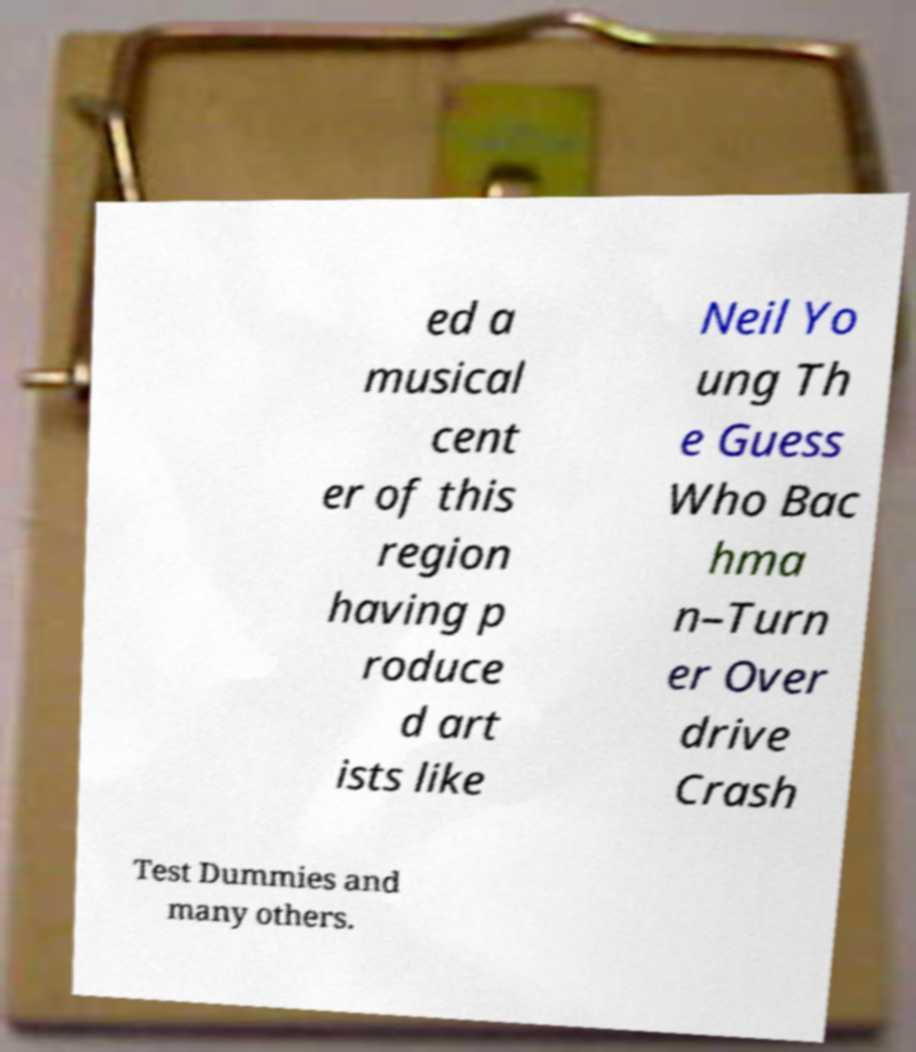Could you assist in decoding the text presented in this image and type it out clearly? ed a musical cent er of this region having p roduce d art ists like Neil Yo ung Th e Guess Who Bac hma n–Turn er Over drive Crash Test Dummies and many others. 